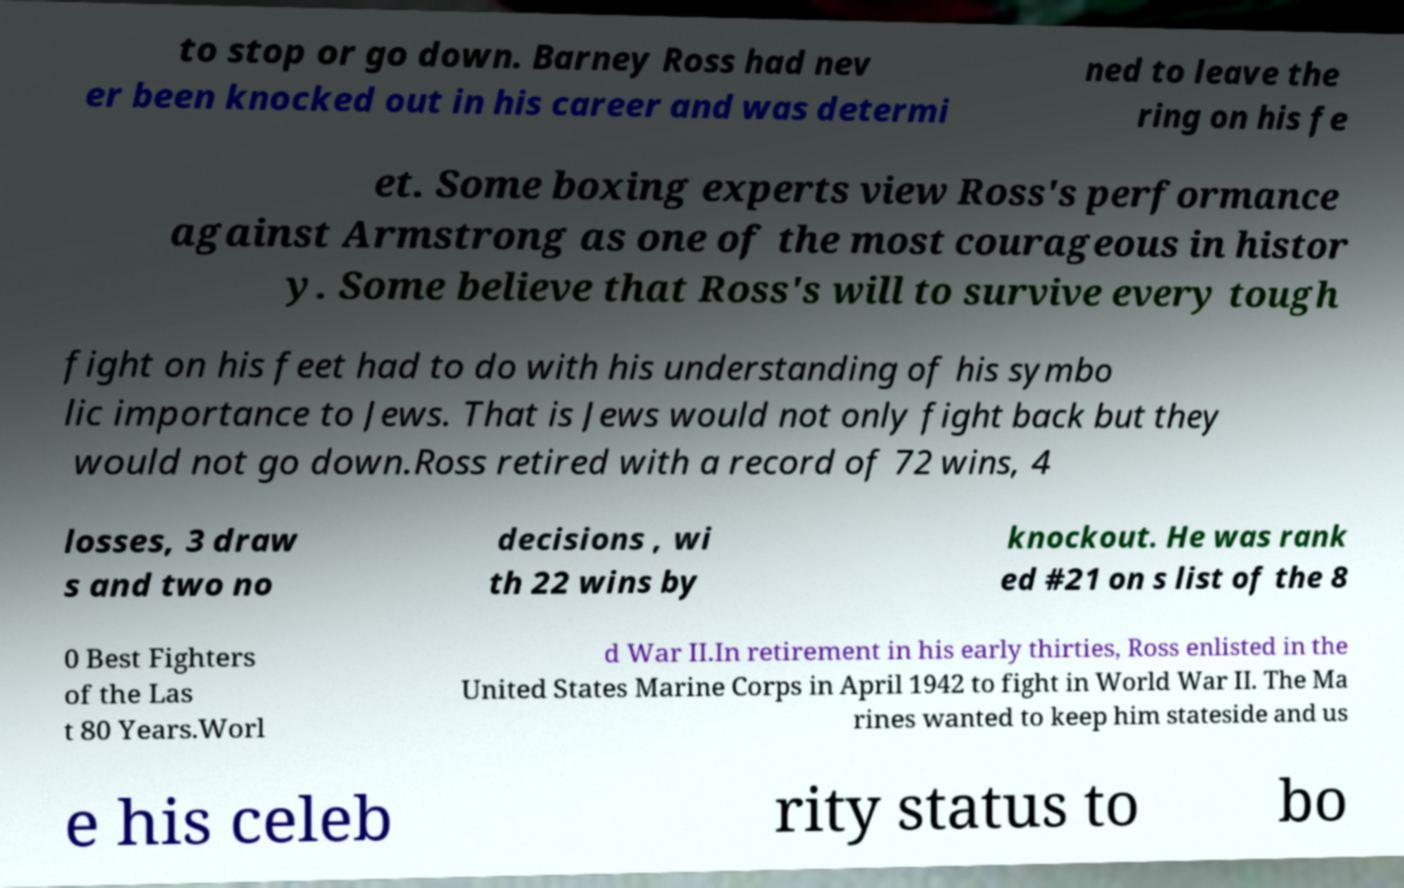Could you assist in decoding the text presented in this image and type it out clearly? to stop or go down. Barney Ross had nev er been knocked out in his career and was determi ned to leave the ring on his fe et. Some boxing experts view Ross's performance against Armstrong as one of the most courageous in histor y. Some believe that Ross's will to survive every tough fight on his feet had to do with his understanding of his symbo lic importance to Jews. That is Jews would not only fight back but they would not go down.Ross retired with a record of 72 wins, 4 losses, 3 draw s and two no decisions , wi th 22 wins by knockout. He was rank ed #21 on s list of the 8 0 Best Fighters of the Las t 80 Years.Worl d War II.In retirement in his early thirties, Ross enlisted in the United States Marine Corps in April 1942 to fight in World War II. The Ma rines wanted to keep him stateside and us e his celeb rity status to bo 